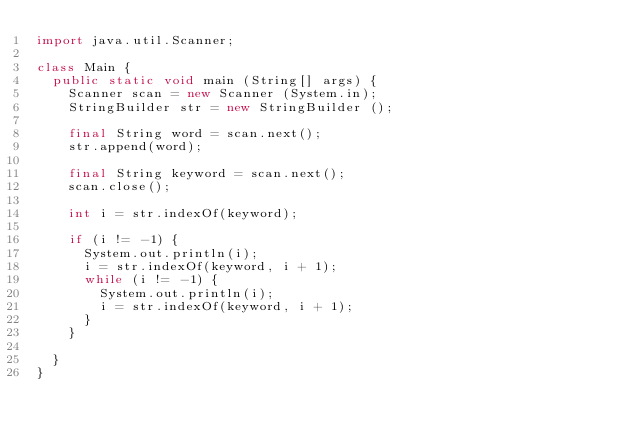Convert code to text. <code><loc_0><loc_0><loc_500><loc_500><_Java_>import java.util.Scanner;

class Main {
	public static void main (String[] args) {
		Scanner scan = new Scanner (System.in);
		StringBuilder str = new StringBuilder ();
		
		final String word = scan.next();
		str.append(word);
		
		final String keyword = scan.next();
		scan.close();
		
		int i = str.indexOf(keyword);
		
		if (i != -1) {
			System.out.println(i);
			i = str.indexOf(keyword, i + 1);
			while (i != -1) {
				System.out.println(i);
				i = str.indexOf(keyword, i + 1);
			}
		}
		
	}
}

</code> 